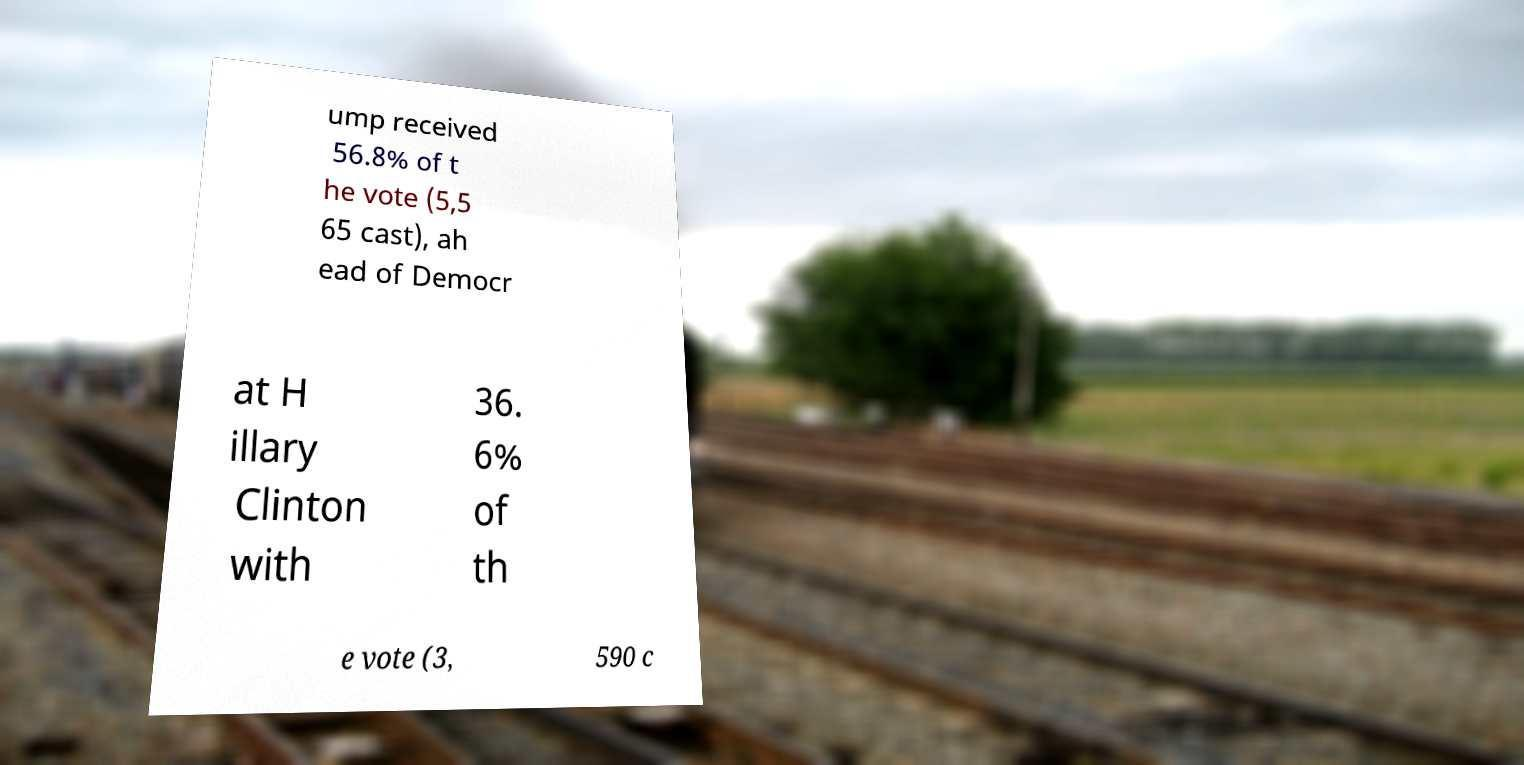Please identify and transcribe the text found in this image. ump received 56.8% of t he vote (5,5 65 cast), ah ead of Democr at H illary Clinton with 36. 6% of th e vote (3, 590 c 